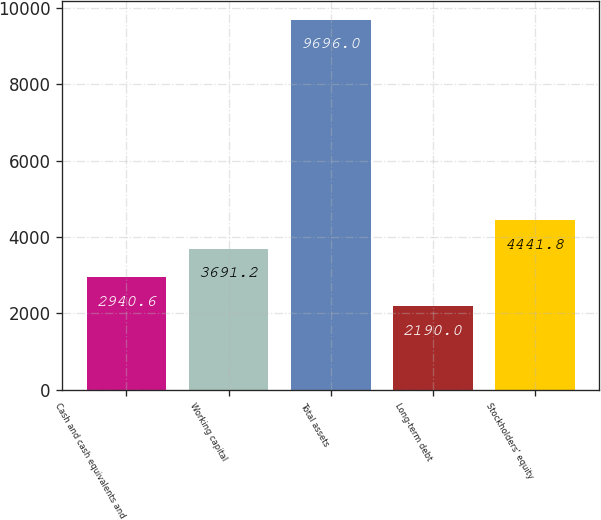Convert chart. <chart><loc_0><loc_0><loc_500><loc_500><bar_chart><fcel>Cash and cash equivalents and<fcel>Working capital<fcel>Total assets<fcel>Long-term debt<fcel>Stockholders' equity<nl><fcel>2940.6<fcel>3691.2<fcel>9696<fcel>2190<fcel>4441.8<nl></chart> 